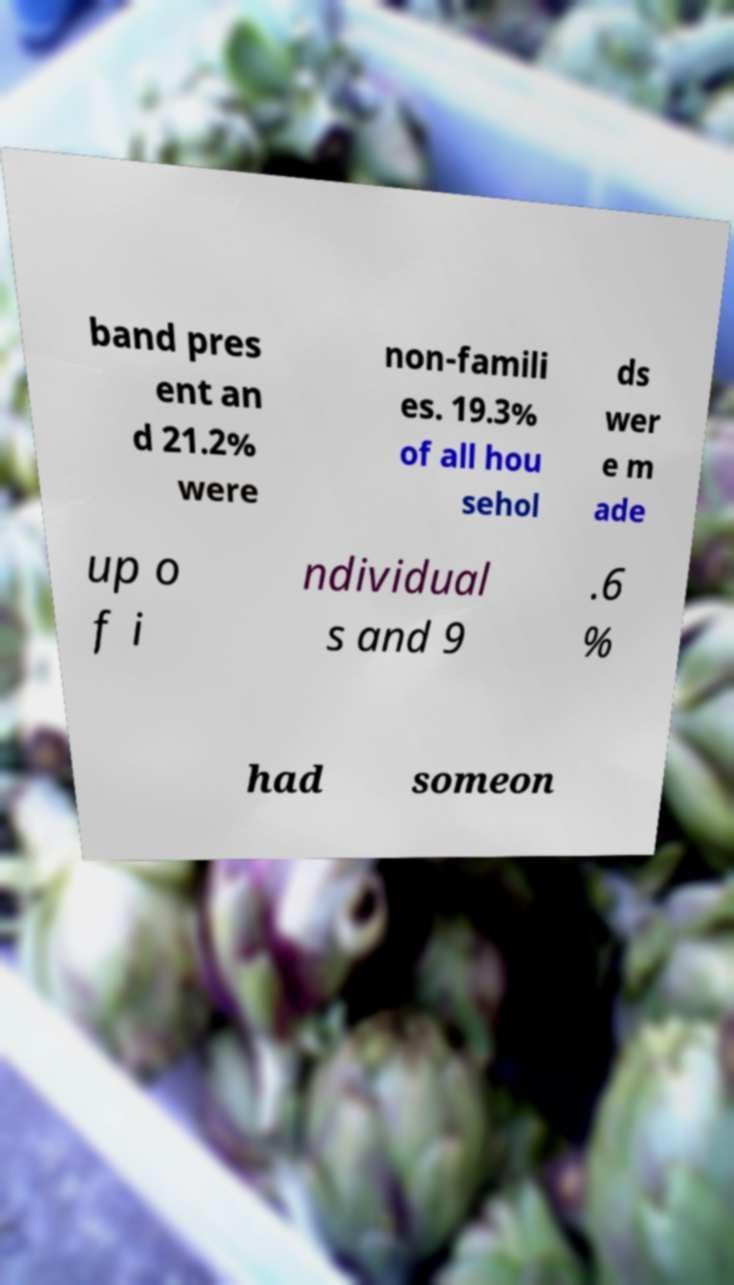Can you accurately transcribe the text from the provided image for me? band pres ent an d 21.2% were non-famili es. 19.3% of all hou sehol ds wer e m ade up o f i ndividual s and 9 .6 % had someon 